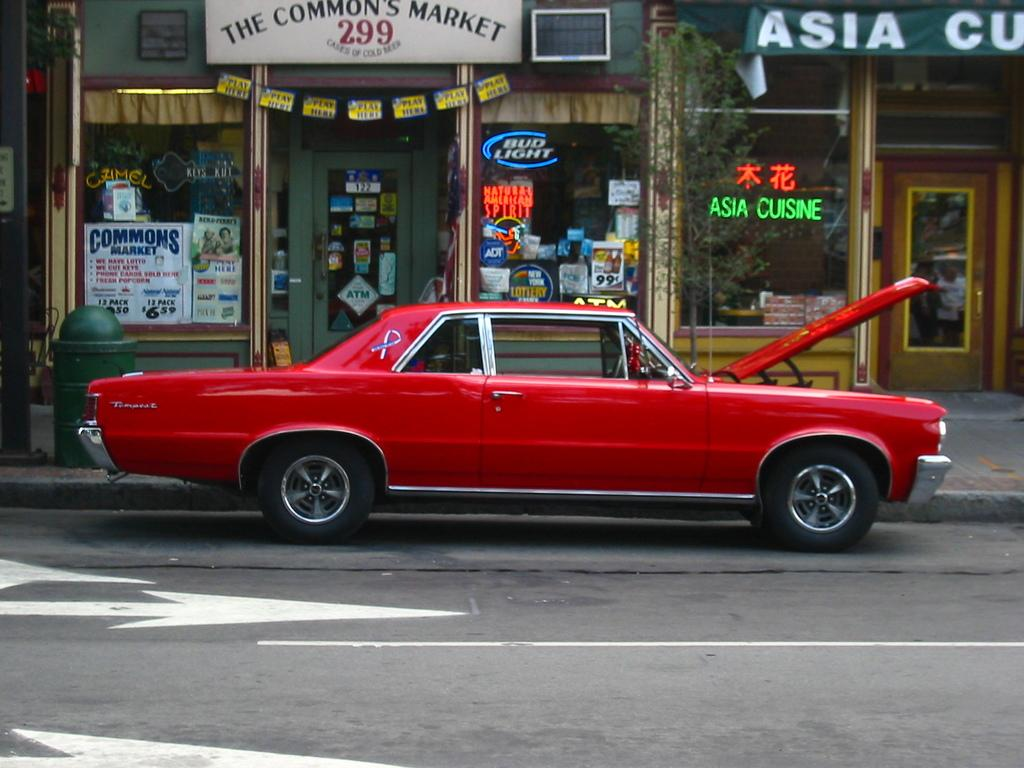What type of vehicle is on the road in the image? There is a red car on the road in the image. What other items can be seen in the image besides the car? There are posters, banners, a name board, and other objects visible in the image. What might the posters and banners be advertising or promoting? It is not possible to determine the exact content of the posters and banners from the image alone. What is the name board used for in the image? The name board might be used to identify a location or business in the image. What type of wax is being used to create the animal sculptures in the image? There are no animal sculptures present in the image, so it is not possible to determine what type of wax might be used. 